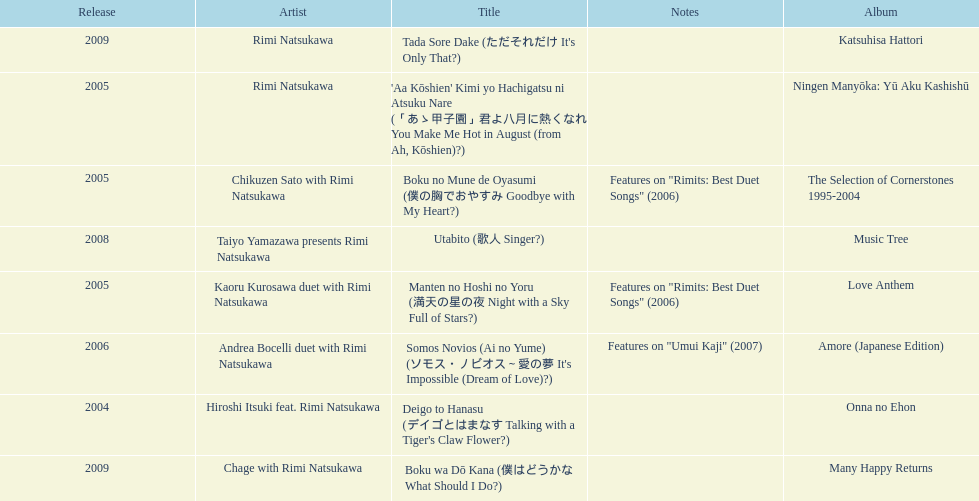What was the album released immediately before the one that had boku wa do kana on it? Music Tree. Help me parse the entirety of this table. {'header': ['Release', 'Artist', 'Title', 'Notes', 'Album'], 'rows': [['2009', 'Rimi Natsukawa', "Tada Sore Dake (ただそれだけ It's Only That?)", '', 'Katsuhisa Hattori'], ['2005', 'Rimi Natsukawa', "'Aa Kōshien' Kimi yo Hachigatsu ni Atsuku Nare (「あゝ甲子園」君よ八月に熱くなれ You Make Me Hot in August (from Ah, Kōshien)?)", '', 'Ningen Manyōka: Yū Aku Kashishū'], ['2005', 'Chikuzen Sato with Rimi Natsukawa', 'Boku no Mune de Oyasumi (僕の胸でおやすみ Goodbye with My Heart?)', 'Features on "Rimits: Best Duet Songs" (2006)', 'The Selection of Cornerstones 1995-2004'], ['2008', 'Taiyo Yamazawa presents Rimi Natsukawa', 'Utabito (歌人 Singer?)', '', 'Music Tree'], ['2005', 'Kaoru Kurosawa duet with Rimi Natsukawa', 'Manten no Hoshi no Yoru (満天の星の夜 Night with a Sky Full of Stars?)', 'Features on "Rimits: Best Duet Songs" (2006)', 'Love Anthem'], ['2006', 'Andrea Bocelli duet with Rimi Natsukawa', "Somos Novios (Ai no Yume) (ソモス・ノビオス～愛の夢 It's Impossible (Dream of Love)?)", 'Features on "Umui Kaji" (2007)', 'Amore (Japanese Edition)'], ['2004', 'Hiroshi Itsuki feat. Rimi Natsukawa', "Deigo to Hanasu (デイゴとはまなす Talking with a Tiger's Claw Flower?)", '', 'Onna no Ehon'], ['2009', 'Chage with Rimi Natsukawa', 'Boku wa Dō Kana (僕はどうかな What Should I Do?)', '', 'Many Happy Returns']]} 